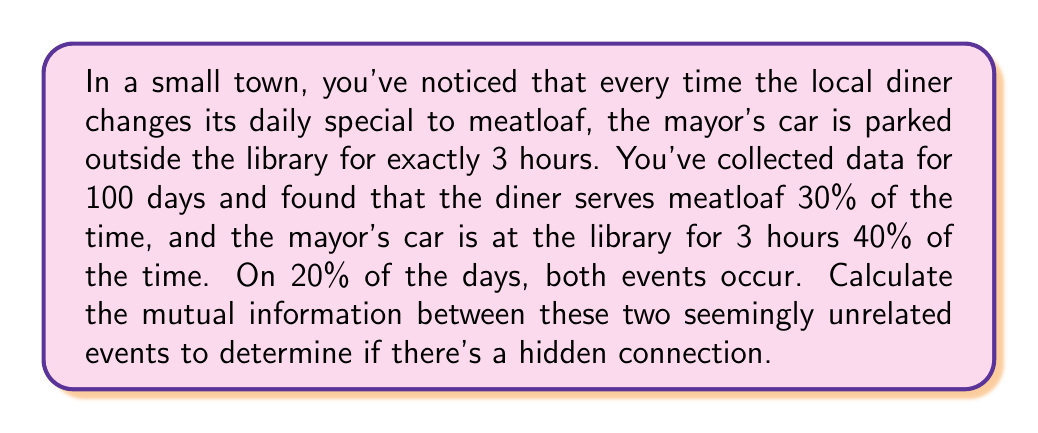What is the answer to this math problem? To calculate the mutual information between two events, we need to use the following formula:

$$I(X;Y) = \sum_{x \in X} \sum_{y \in Y} p(x,y) \log_2 \left(\frac{p(x,y)}{p(x)p(y)}\right)$$

Where:
$X$ is the event of the diner serving meatloaf
$Y$ is the event of the mayor's car being at the library for 3 hours

Let's define our probabilities:

$p(X=1) = 0.3$ (meatloaf is served)
$p(X=0) = 0.7$ (meatloaf is not served)
$p(Y=1) = 0.4$ (mayor's car is at the library)
$p(Y=0) = 0.6$ (mayor's car is not at the library)
$p(X=1, Y=1) = 0.2$ (both events occur)

We can calculate the other joint probabilities:

$p(X=1, Y=0) = p(X=1) - p(X=1, Y=1) = 0.3 - 0.2 = 0.1$
$p(X=0, Y=1) = p(Y=1) - p(X=1, Y=1) = 0.4 - 0.2 = 0.2$
$p(X=0, Y=0) = 1 - p(X=1, Y=1) - p(X=1, Y=0) - p(X=0, Y=1) = 1 - 0.2 - 0.1 - 0.2 = 0.5$

Now, let's calculate each term of the mutual information:

1. $p(1,1) \log_2 \left(\frac{p(1,1)}{p(1)p(1)}\right) = 0.2 \log_2 \left(\frac{0.2}{0.3 \cdot 0.4}\right) \approx 0.2 \cdot 0.7370 = 0.1474$

2. $p(1,0) \log_2 \left(\frac{p(1,0)}{p(1)p(0)}\right) = 0.1 \log_2 \left(\frac{0.1}{0.3 \cdot 0.6}\right) \approx 0.1 \cdot (-0.8074) = -0.0807$

3. $p(0,1) \log_2 \left(\frac{p(0,1)}{p(0)p(1)}\right) = 0.2 \log_2 \left(\frac{0.2}{0.7 \cdot 0.4}\right) \approx 0.2 \cdot (-0.4854) = -0.0971$

4. $p(0,0) \log_2 \left(\frac{p(0,0)}{p(0)p(0)}\right) = 0.5 \log_2 \left(\frac{0.5}{0.7 \cdot 0.6}\right) \approx 0.5 \cdot 0.2630 = 0.1315$

Sum all these terms to get the mutual information:

$$I(X;Y) = 0.1474 - 0.0807 - 0.0971 + 0.1315 = 0.1011 \text{ bits}$$
Answer: The mutual information between the diner serving meatloaf and the mayor's car being at the library for 3 hours is approximately 0.1011 bits. 